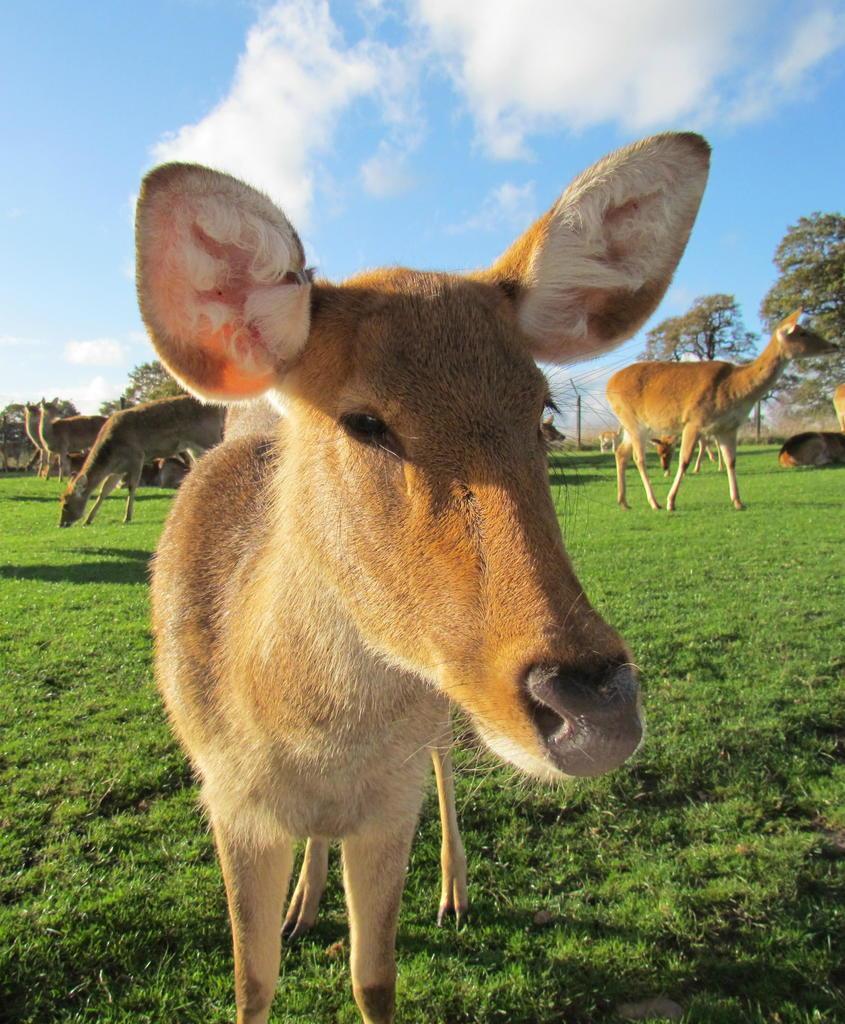Describe this image in one or two sentences. In this image I can see few animals in brown and cream color. Background I can see grass and trees in green color and the sky is in blue and white color. 